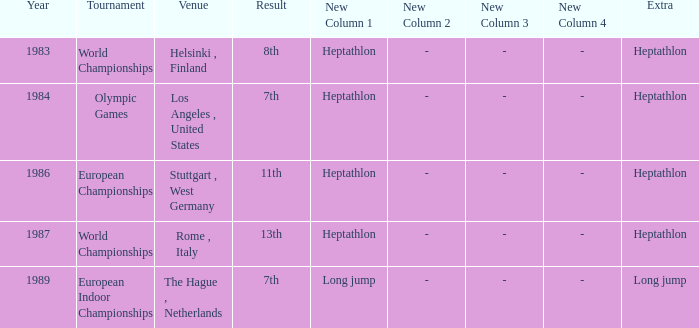Where was the 1984 Olympics hosted? Olympic Games. 